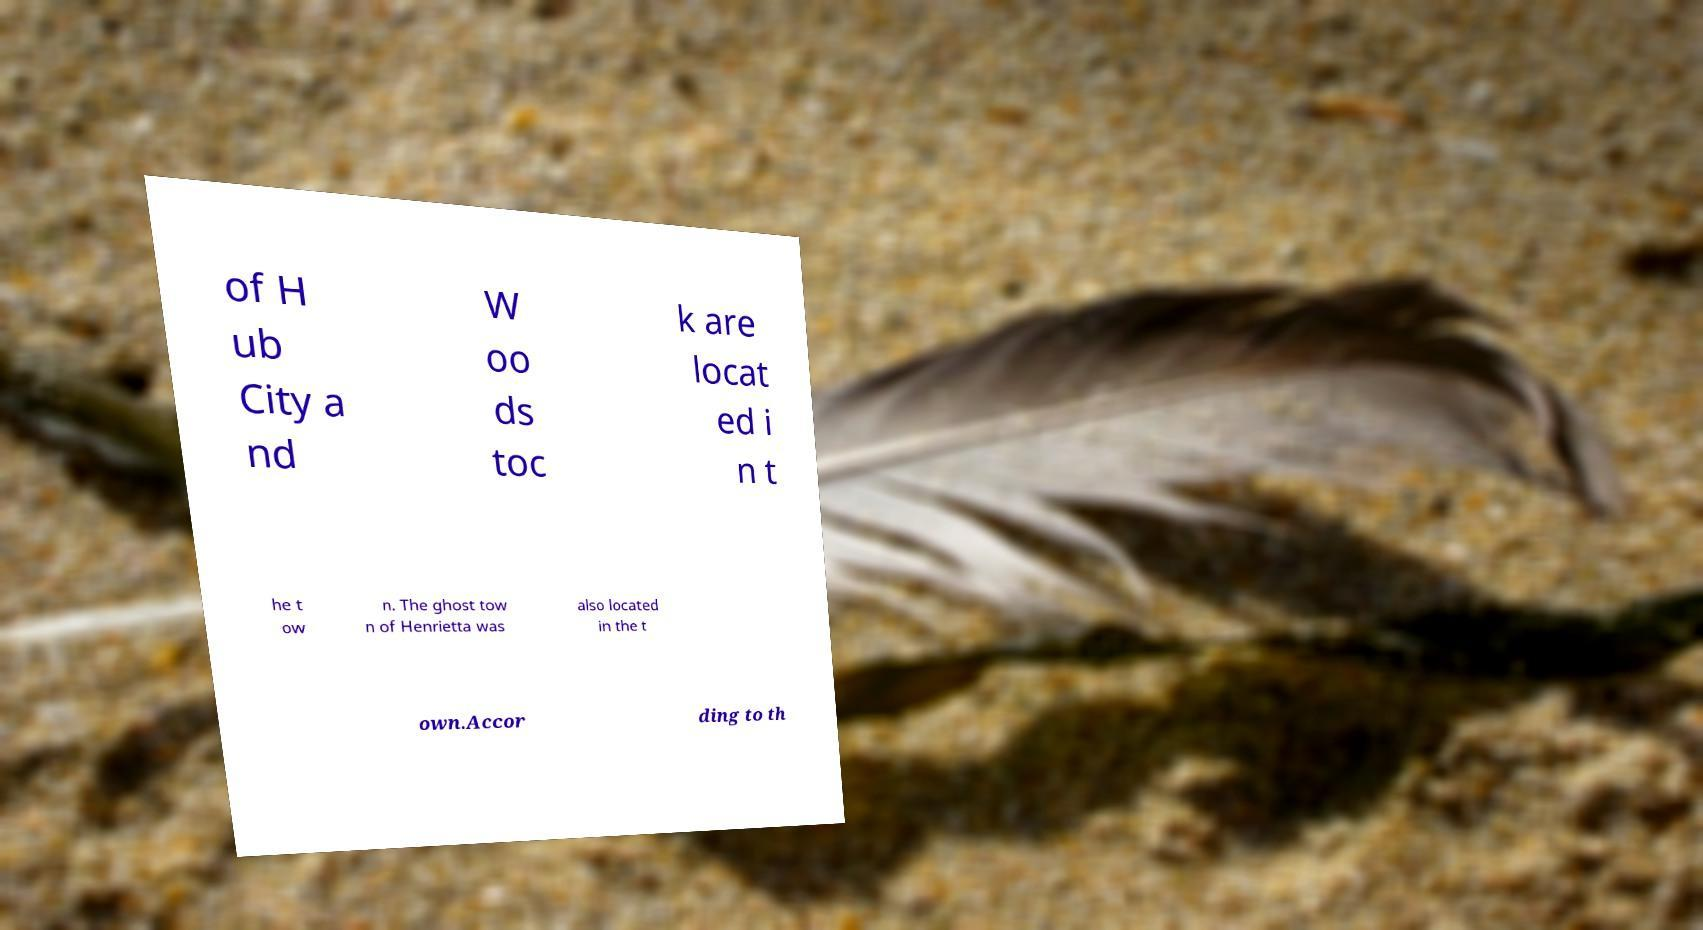Could you assist in decoding the text presented in this image and type it out clearly? of H ub City a nd W oo ds toc k are locat ed i n t he t ow n. The ghost tow n of Henrietta was also located in the t own.Accor ding to th 